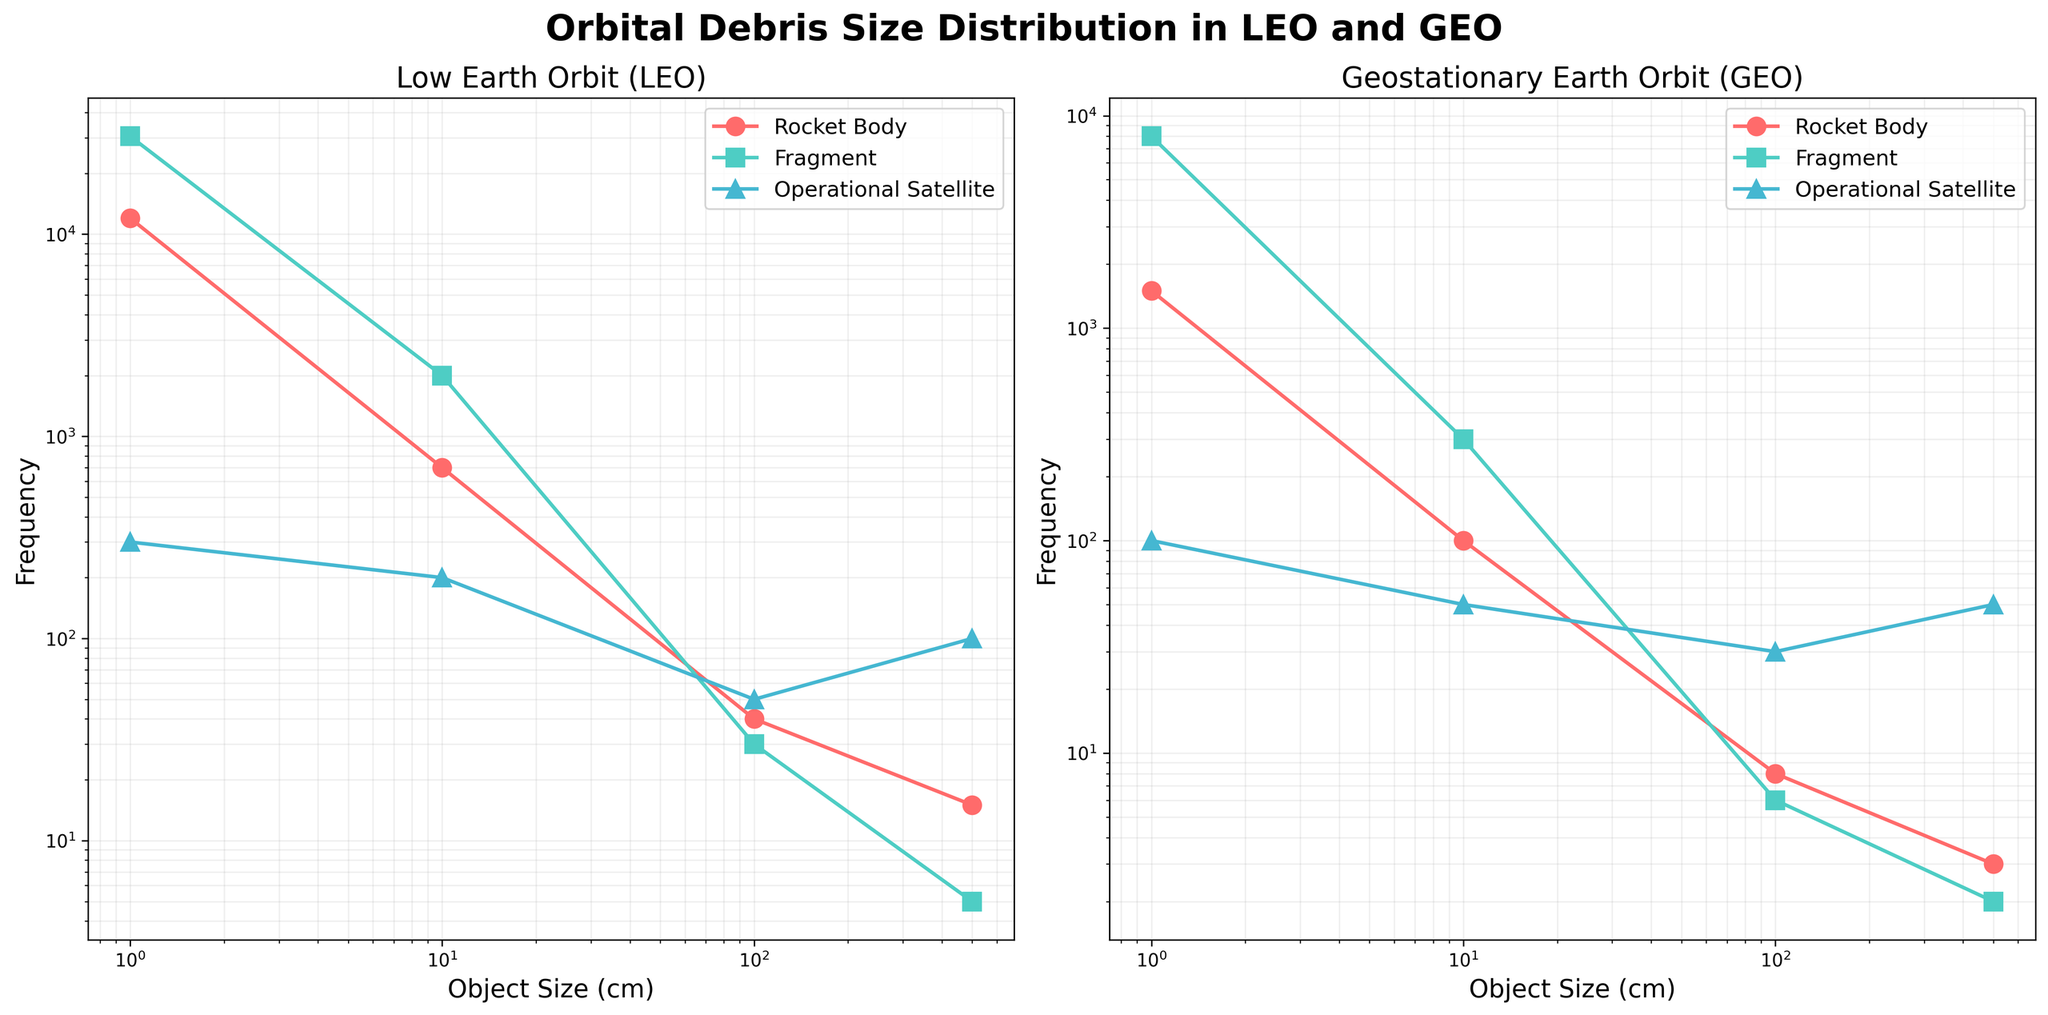What's the title of the figure? The title is located at the top center of the figure and it states: "Orbital Debris Size Distribution in LEO and GEO".
Answer: Orbital Debris Size Distribution in LEO and GEO Which axis represents the object size? On both subplots, the x-axis represents the `Object Size` and it is labeled `Object Size (cm)`.
Answer: x-axis Which object type has the highest frequency for 1 cm size in LEO? From the LEO subplot, it is visible that `Fragment` has the highest frequency for the 1 cm size, represented by the point on the pinkish line at about 30,500.
Answer: Fragment How does the frequency of fragments in GEO compare to LEO for objects of size 1 cm? The frequency of `Fragments` of size 1 cm in GEO is shown at around 8,000, whereas in LEO, it's around 30,500. Thus, LEO has a higher frequency of fragments of size 1 cm compared to GEO.
Answer: LEO has higher frequency What is the trend of frequency for rocket bodies in LEO as object size decreases from 500 cm to 1 cm? In the LEO subplot, the frequency of `Rocket Body` increases as the object size decreases from 500 cm to 1 cm. The points on the pinkish line show the upward trend from 15 to around 12,000.
Answer: Increasing Between LEO and GEO, which region has more rocket bodies with an object size of 100 cm? On comparing both subplots, LEO has a frequency of 40 rocket bodies of 100 cm size, while GEO has only 8. Therefore, LEO has more.
Answer: LEO Why might operational satellites show different frequencies in LEO compared to GEO across all sizes? The operational requirements and satellite deployment strategies differ for LEO and GEO. Generally, more operational satellites are found in LEO because of its accessibility and various mission profiles, while GEO hosts fewer but crucial communication and weather satellites.
Answer: Different deployment strategies If we sum up the total frequency of all object types in LEO with a size of 10 cm, what would that be? Summing the frequencies for 10 cm objects in LEO: Rocket Body (700) + Fragment (2000) + Operational Satellite (200) gives a total of 2900.
Answer: 2900 Which object type shows the least variation in frequency across different sizes in GEO? Operational Satellites in GEO show relatively less variation in the subplot as their frequency varies slightly between 100, 30, 50, and 100 across sizes unlike the other object types.
Answer: Operational Satellite What pattern can be observed about the frequency of operational satellites in LEO as object size increases from 1 cm to 500 cm? From the LEO subplot, the frequency decreases as the object size increases from 1 cm to 500 cm: starting at 300 and dropping to 100.
Answer: Decreasing 